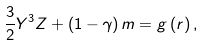Convert formula to latex. <formula><loc_0><loc_0><loc_500><loc_500>\frac { 3 } { 2 } Y ^ { 3 } Z + \left ( 1 - \gamma \right ) m = g \left ( r \right ) ,</formula> 